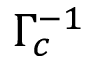Convert formula to latex. <formula><loc_0><loc_0><loc_500><loc_500>\Gamma _ { c } ^ { - 1 }</formula> 